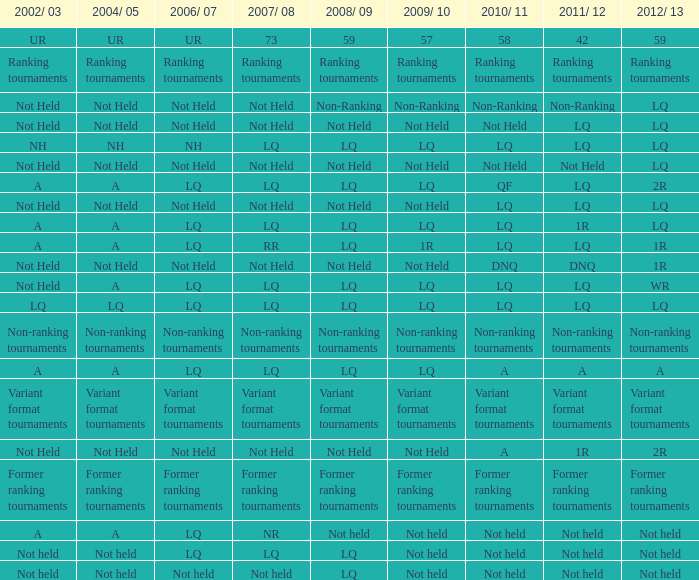Indicate the 2010/11 with 2004/05 of not carried out and 2011/12 of non-ranking. Non-Ranking. 